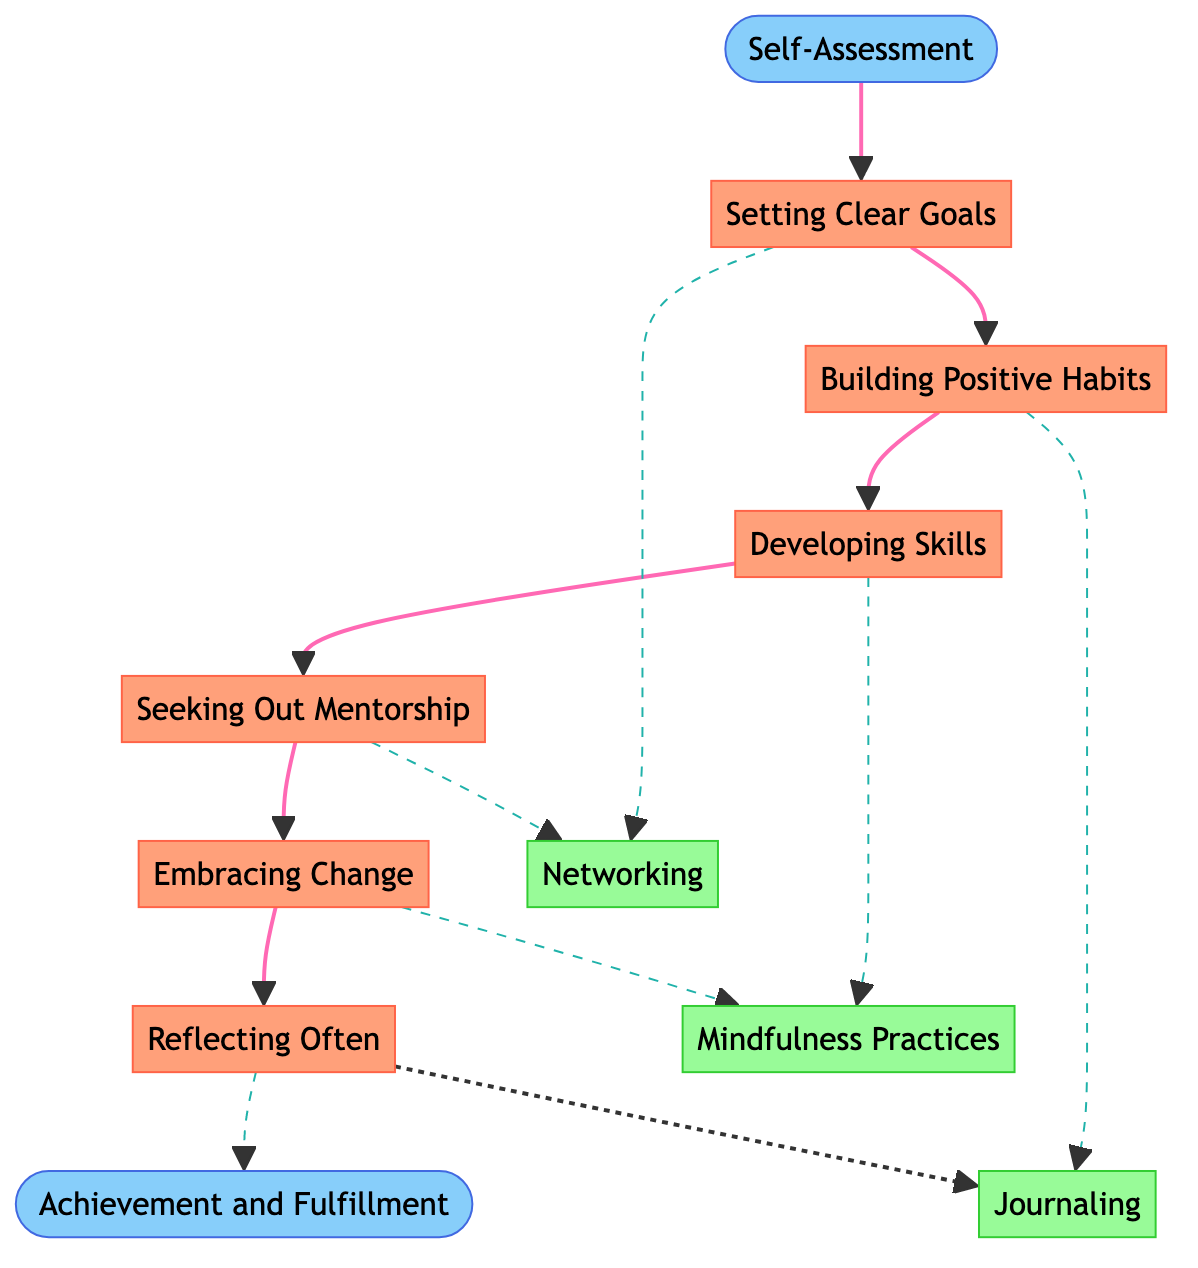What is the starting point of the journey? The starting point of the journey is labeled "Self-Assessment" in the diagram. It is the node from where the personal growth journey begins.
Answer: Self-Assessment What is the end point of the journey? The endpoint of the journey is labeled "Achievement and Fulfillment" in the diagram. This node signifies the ultimate goal of the personal growth journey.
Answer: Achievement and Fulfillment How many milestones are there in the diagram? By counting the nodes labeled as milestones in the diagram, which are between the starting point and the endpoint, we identify six distinct milestones.
Answer: 6 Which milestone follows "Setting Clear Goals"? The flow in the diagram indicates that "Building Positive Habits" is the next milestone that comes after "Setting Clear Goals."
Answer: Building Positive Habits What supporting activity is linked to "Developing Skills"? The diagram shows a dashed arrow connecting "Developing Skills" to "Mindfulness Practices," indicating that this supporting activity is associated with that milestone.
Answer: Mindfulness Practices What are the total number of supporting activities shown in the diagram? Counting the nodes labeled as supporting activities reveals that there are three distinct activities represented in the diagram.
Answer: 3 Which milestone comes just before "Embracing Change"? By following the flow of the milestones in the diagram, we find that "Seeking Out Mentorship" directly precedes "Embracing Change."
Answer: Seeking Out Mentorship Which supporting activities are connected to "Reflecting Often"? The diagram illustrates a dashed line linking "Reflecting Often" to "Journaling," meaning this is the activity associated with that milestone.
Answer: Journaling How do "Networking" and "Seeking Out Mentorship" relate in the diagram? Both "Networking" and "Seeking Out Mentorship" are associated with the importance of connecting with others; however, the diagram specifically illustrates that "Networking" relates to multiple milestones while "Seeking Out Mentorship" is a direct link to only one milestone.
Answer: Multiple connections What color are the milestone nodes in the diagram? The milestone nodes are specifically colored in a shade of peach as defined in the diagram styling, indicated by the fill color of #FFA07A.
Answer: Peach 